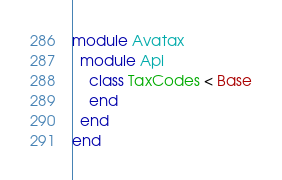<code> <loc_0><loc_0><loc_500><loc_500><_Ruby_>module Avatax
  module Api
    class TaxCodes < Base
    end
  end
end
</code> 